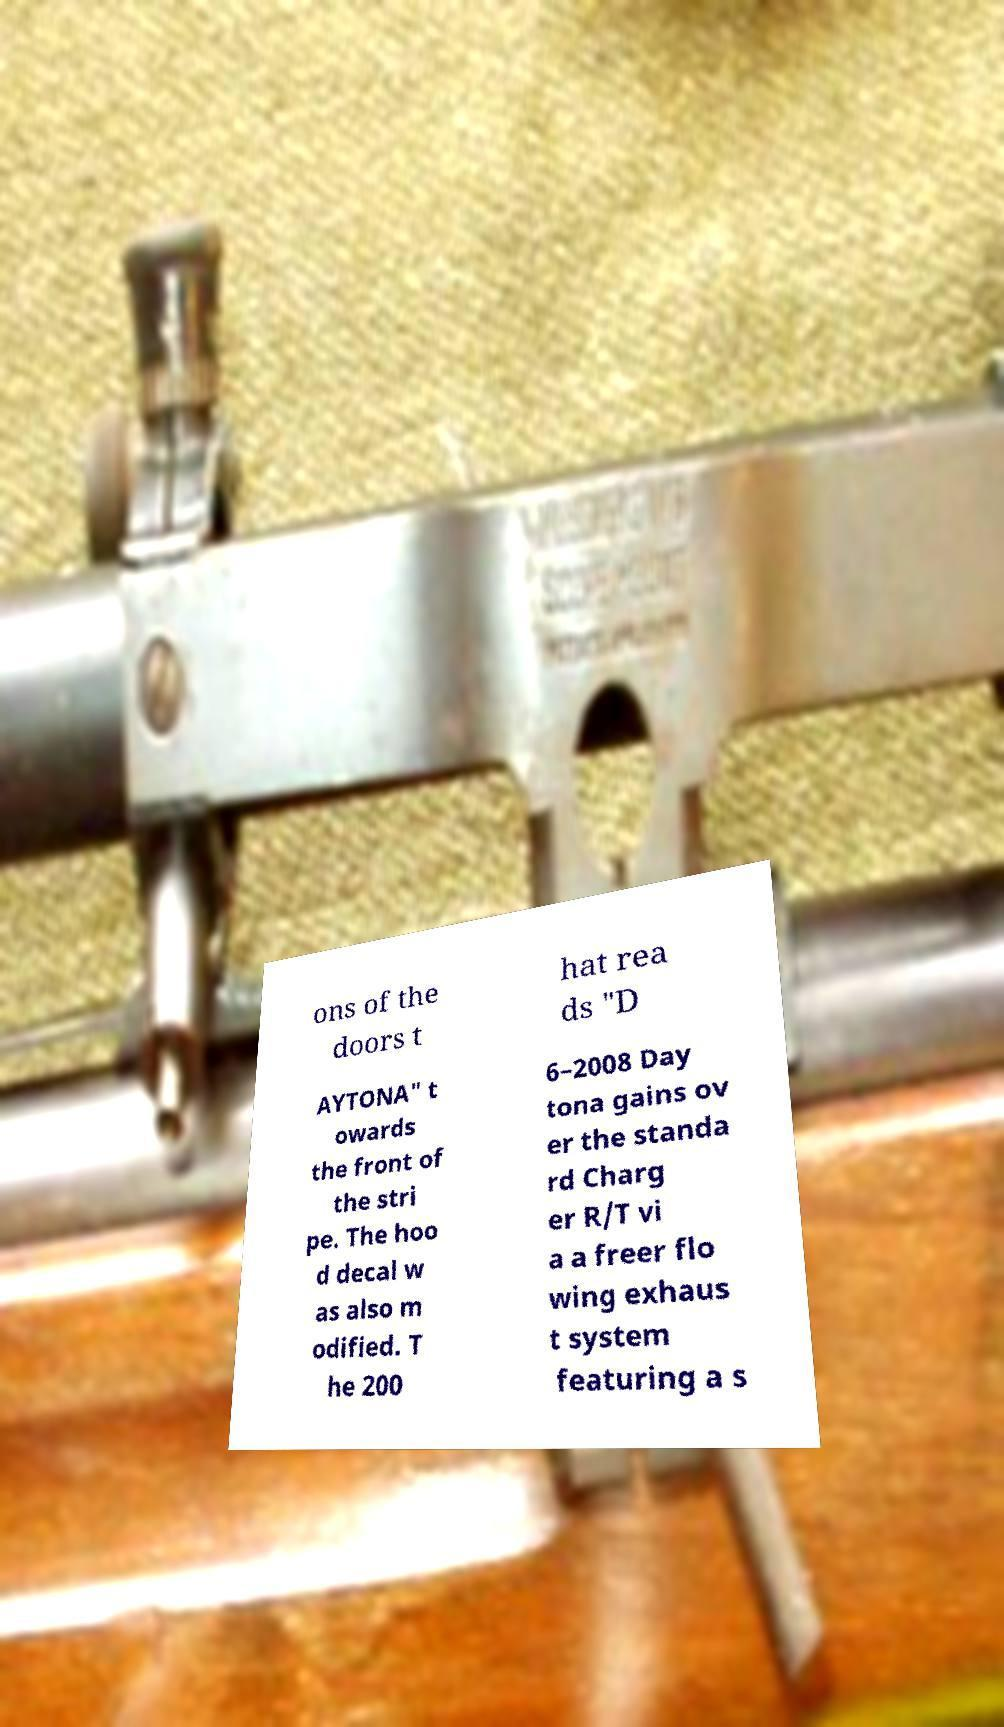Can you read and provide the text displayed in the image?This photo seems to have some interesting text. Can you extract and type it out for me? ons of the doors t hat rea ds "D AYTONA" t owards the front of the stri pe. The hoo d decal w as also m odified. T he 200 6–2008 Day tona gains ov er the standa rd Charg er R/T vi a a freer flo wing exhaus t system featuring a s 